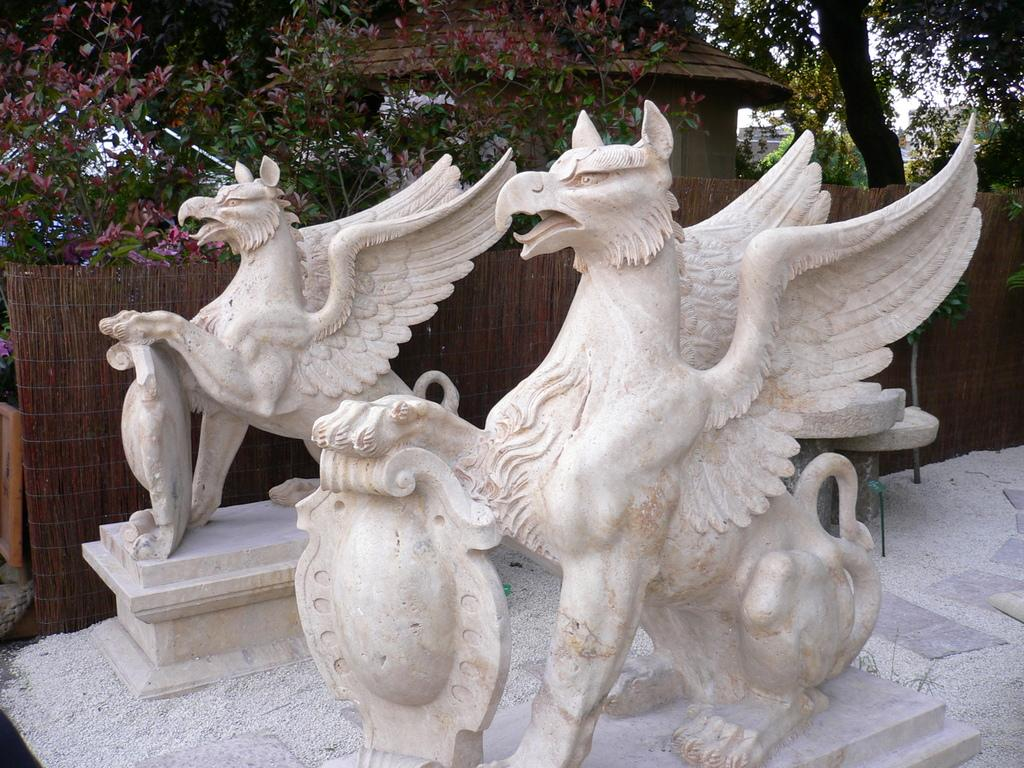What type of art is present in the image? There are sculptures in the image. What can be seen in the distance behind the sculptures? There are trees, a house, a fence, and other objects in the background of the image. What is visible in the sky in the image? The sky is visible in the background of the image. What type of arch can be seen in the image? There is no arch present in the image. What emotion is being expressed by the sculptures in the image? The sculptures themselves do not express emotions, as they are inanimate objects. 